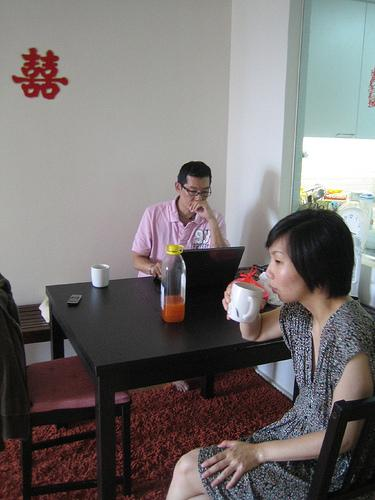Why is the woman blowing on the mug? Please explain your reasoning. to cool. A woman is holding a mug and blowing. people blow on hot things to cool them. 